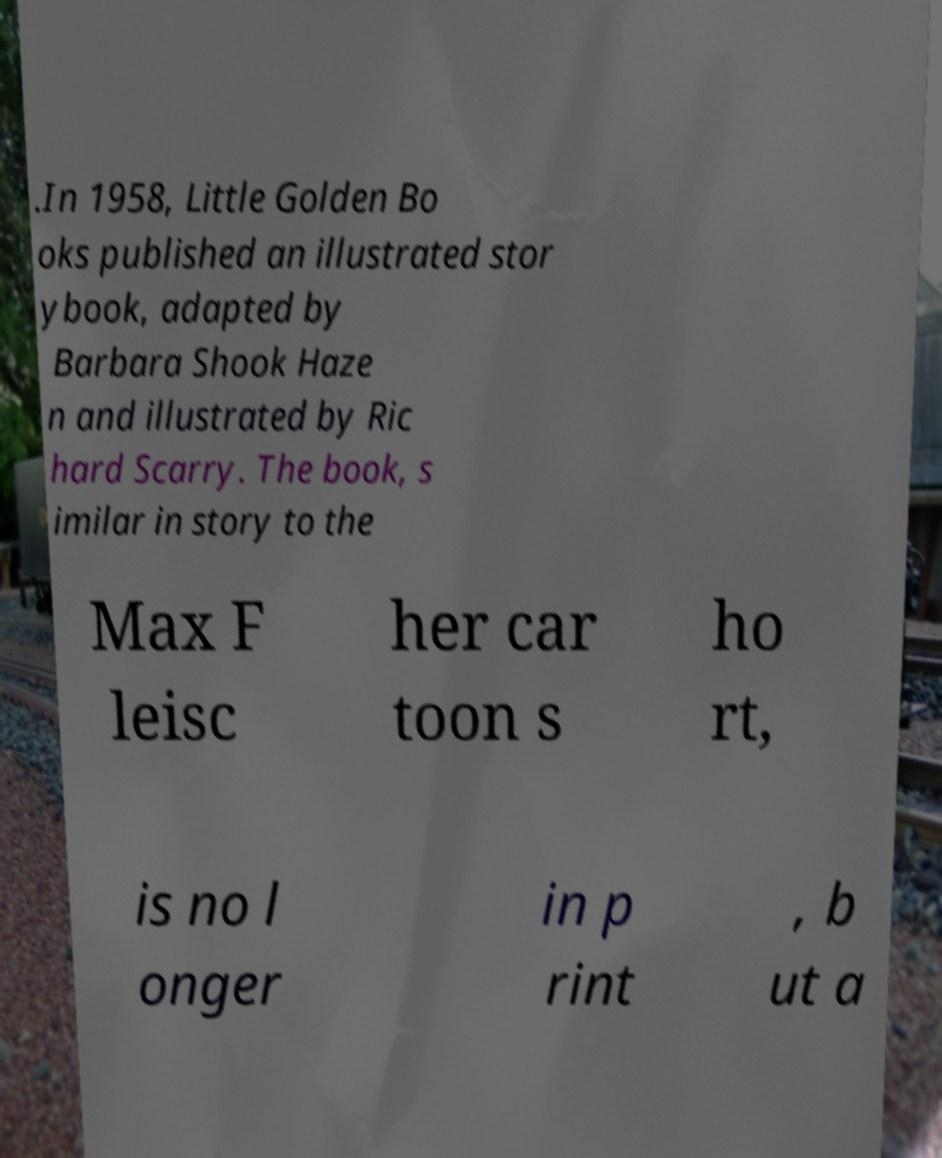Can you accurately transcribe the text from the provided image for me? .In 1958, Little Golden Bo oks published an illustrated stor ybook, adapted by Barbara Shook Haze n and illustrated by Ric hard Scarry. The book, s imilar in story to the Max F leisc her car toon s ho rt, is no l onger in p rint , b ut a 